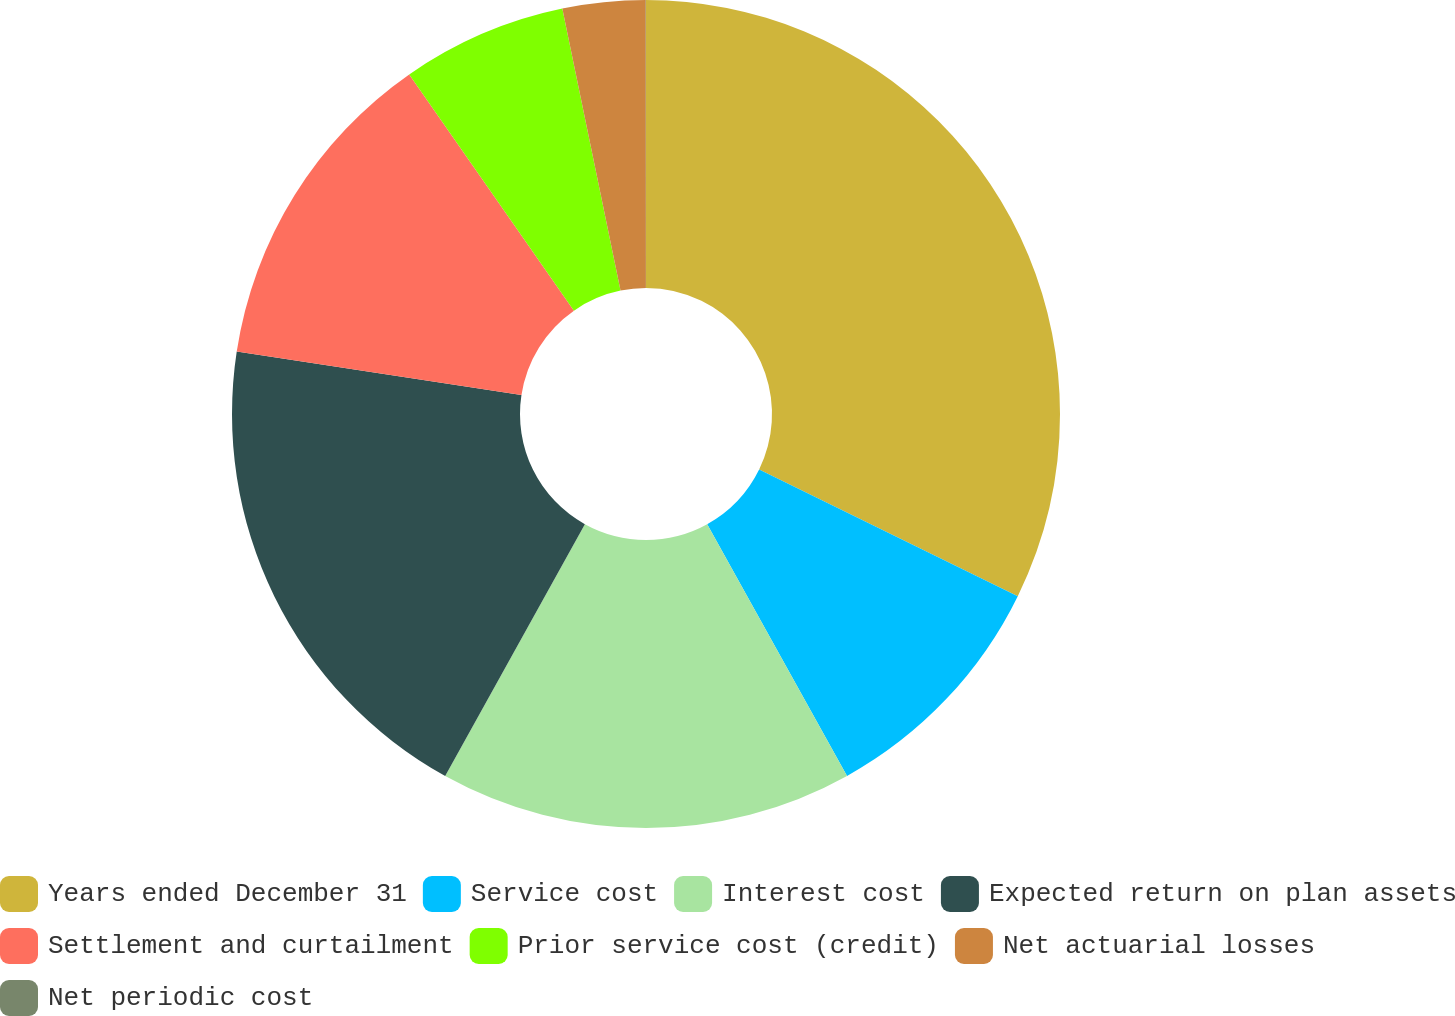Convert chart. <chart><loc_0><loc_0><loc_500><loc_500><pie_chart><fcel>Years ended December 31<fcel>Service cost<fcel>Interest cost<fcel>Expected return on plan assets<fcel>Settlement and curtailment<fcel>Prior service cost (credit)<fcel>Net actuarial losses<fcel>Net periodic cost<nl><fcel>32.25%<fcel>9.68%<fcel>16.13%<fcel>19.35%<fcel>12.9%<fcel>6.45%<fcel>3.23%<fcel>0.01%<nl></chart> 